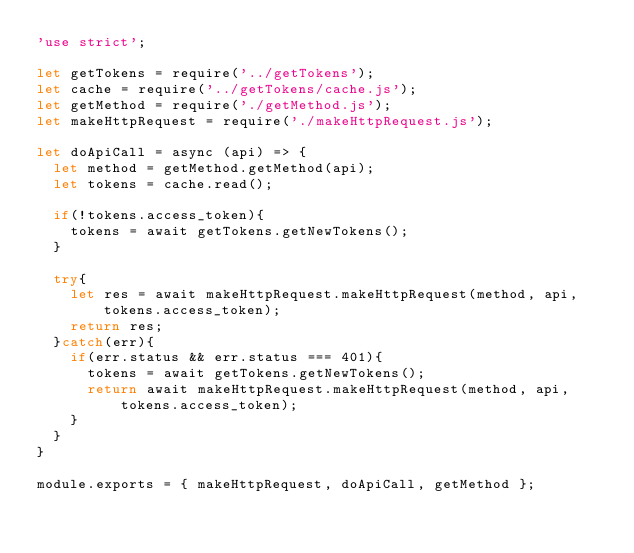Convert code to text. <code><loc_0><loc_0><loc_500><loc_500><_JavaScript_>'use strict';

let getTokens = require('../getTokens');
let cache = require('../getTokens/cache.js');
let getMethod = require('./getMethod.js');
let makeHttpRequest = require('./makeHttpRequest.js');

let doApiCall = async (api) => {
  let method = getMethod.getMethod(api);
  let tokens = cache.read();

  if(!tokens.access_token){
    tokens = await getTokens.getNewTokens();
  }

  try{
    let res = await makeHttpRequest.makeHttpRequest(method, api, tokens.access_token);
    return res;
  }catch(err){
    if(err.status && err.status === 401){
      tokens = await getTokens.getNewTokens();
      return await makeHttpRequest.makeHttpRequest(method, api, tokens.access_token);
    }
  }
}

module.exports = { makeHttpRequest, doApiCall, getMethod };
</code> 